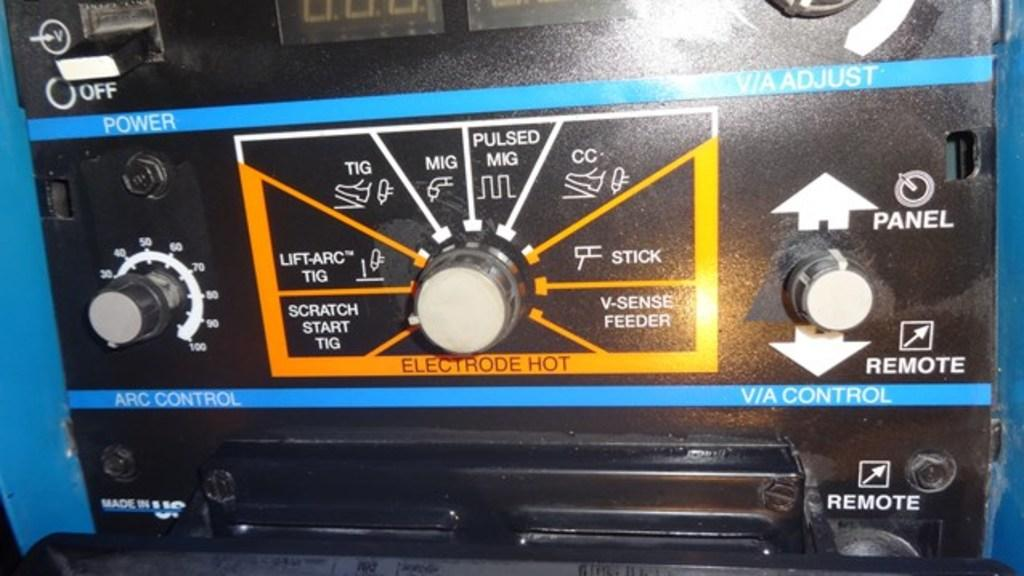What is the main subject of the image? The main subject of the image is an object related to vehicle audio. What can be seen on the object? There are buttons on either side of the object. What else is present in the image? There is a yellow color line with text written on it in the image. What type of umbrella is being used to protect the object from the weather in the image? There is no umbrella or weather mentioned in the image; it only features an object related to vehicle audio with buttons and a yellow color line with text. 